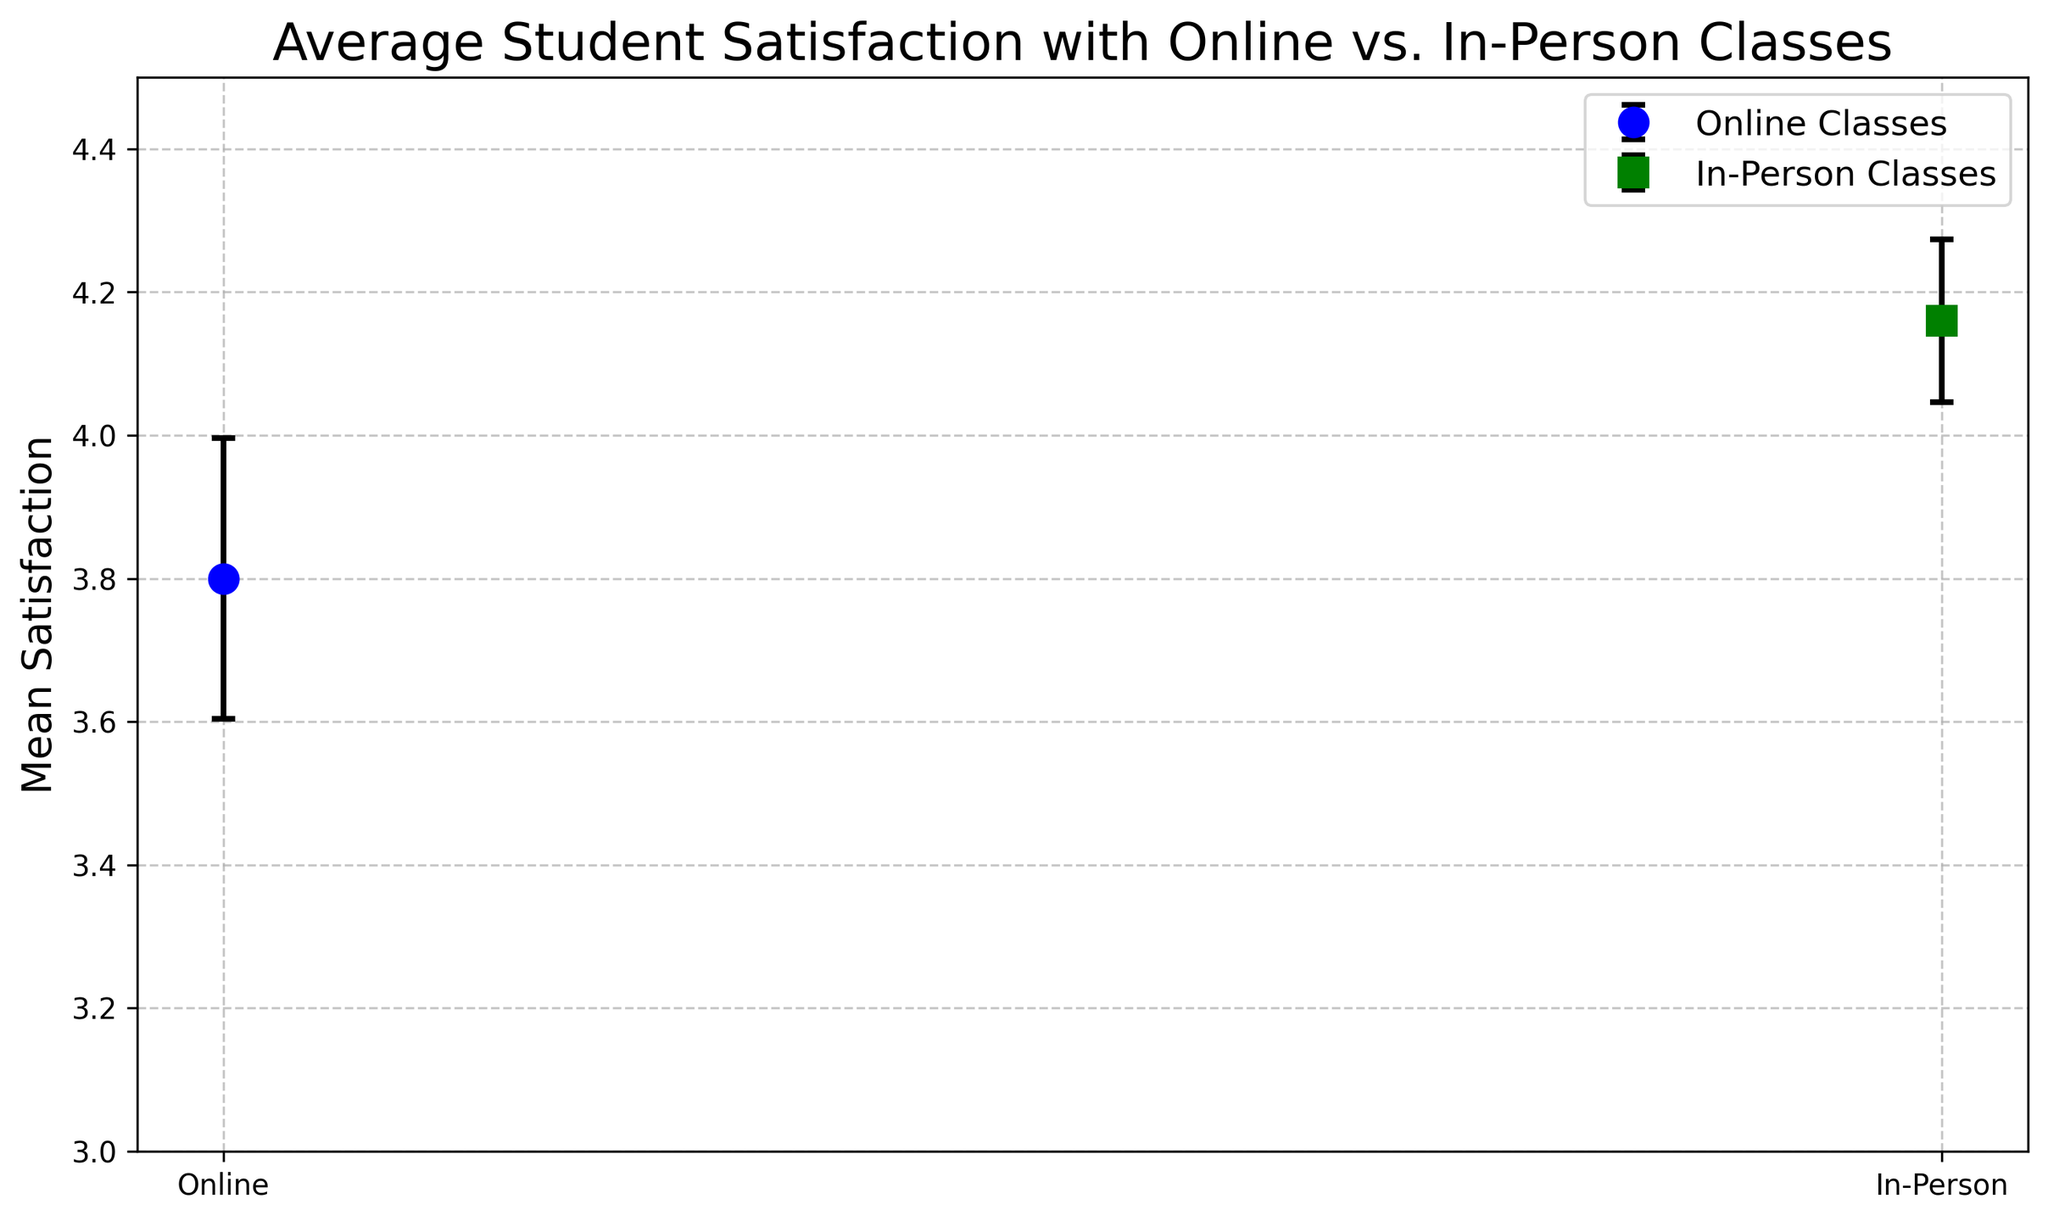How many satisfaction levels are displayed in the figure? The figure shows data for two types of classes: Online and In-Person.
Answer: 2 Which type of class has the higher average mean satisfaction? Comparing the mean satisfaction levels, In-Person classes have a mean satisfaction higher than Online classes.
Answer: In-Person What is the average mean satisfaction for Online classes? Summing the mean satisfaction values for Online classes (3.8, 3.6, 4.0, 3.7, 3.9) and then dividing by the number of values gives (3.8 + 3.6 + 4.0 + 3.7 + 3.9)/5 = 19/5 = 3.8
Answer: 3.8 Which error bar is longer, Online or In-Person classes? Comparing the error bars visually, Online classes have longer error bars because their standard errors (average of 0.2, 0.25, 0.15, 0.2, 0.18) are greater than those of In-Person classes.
Answer: Online What is the average standard error for In-Person classes? Summing the standard error values for In-Person classes (0.1, 0.12, 0.14, 0.1, 0.11) and then dividing by the number of values gives 
(0.1 + 0.12 + 0.14 + 0.1 + 0.11)/5 = 0.57/5 = 0.114
Answer: 0.114 By how much does the mean satisfaction for In-Person classes exceed that of Online classes? The mean satisfaction for In-Person classes is 4.16. For Online classes, it is 3.8. The difference is 4.16 - 3.8 = 0.36
Answer: 0.36 Which class type has the highest individual mean satisfaction value, and what is that value? The table shows the highest individual mean satisfaction value is 4.3 for In-Person classes.
Answer: In-Person, 4.3 What is the mean standard error for Online classes? Summing the standard error values for Online classes (0.2, 0.25, 0.15, 0.2, 0.18) and dividing by the number of values gives 
(0.2 + 0.25 + 0.15 + 0.2 + 0.18)/5 = 0.98/5 = 0.196
Answer: 0.196 Which type of class has more varied (i.e., higher standard error) responses in terms of satisfaction? By comparing the average standard errors of Online (0.196) and In-Person (0.114) classes, Online classes exhibit more variability.
Answer: Online What is the range of standard errors for In-Person classes? The smallest standard error for In-Person is 0.1 and the largest is 0.14, so the range is 0.14 - 0.1 = 0.04
Answer: 0.04 